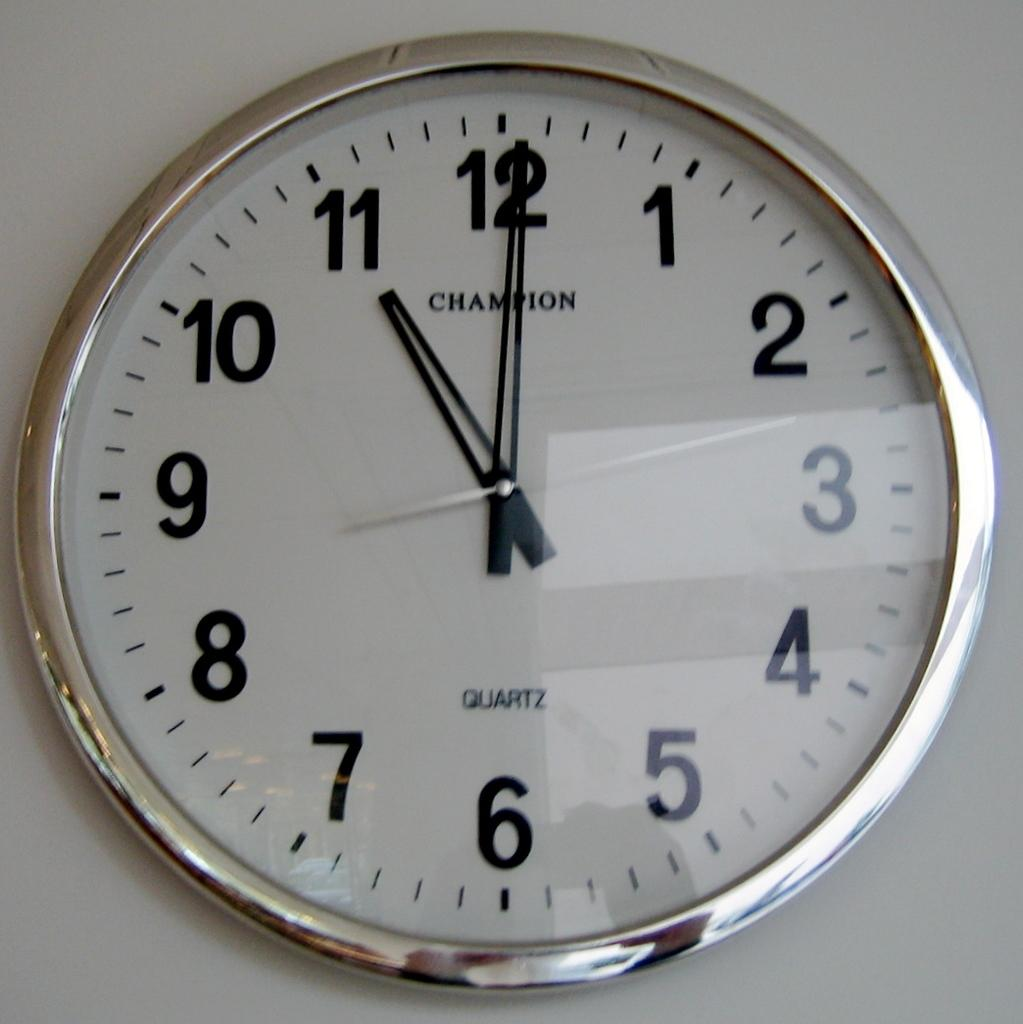<image>
Describe the image concisely. A clock on a white wall shows a time of 11:00. 